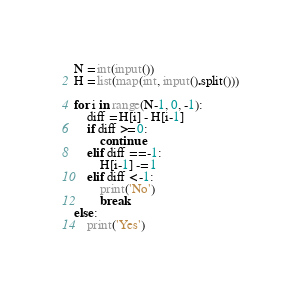Convert code to text. <code><loc_0><loc_0><loc_500><loc_500><_Python_>N = int(input())
H = list(map(int, input().split()))

for i in range(N-1, 0, -1):
    diff = H[i] - H[i-1]
    if diff >= 0:
        continue
    elif diff == -1:
        H[i-1] -= 1
    elif diff < -1:
        print('No')
        break
else:
    print('Yes')
</code> 